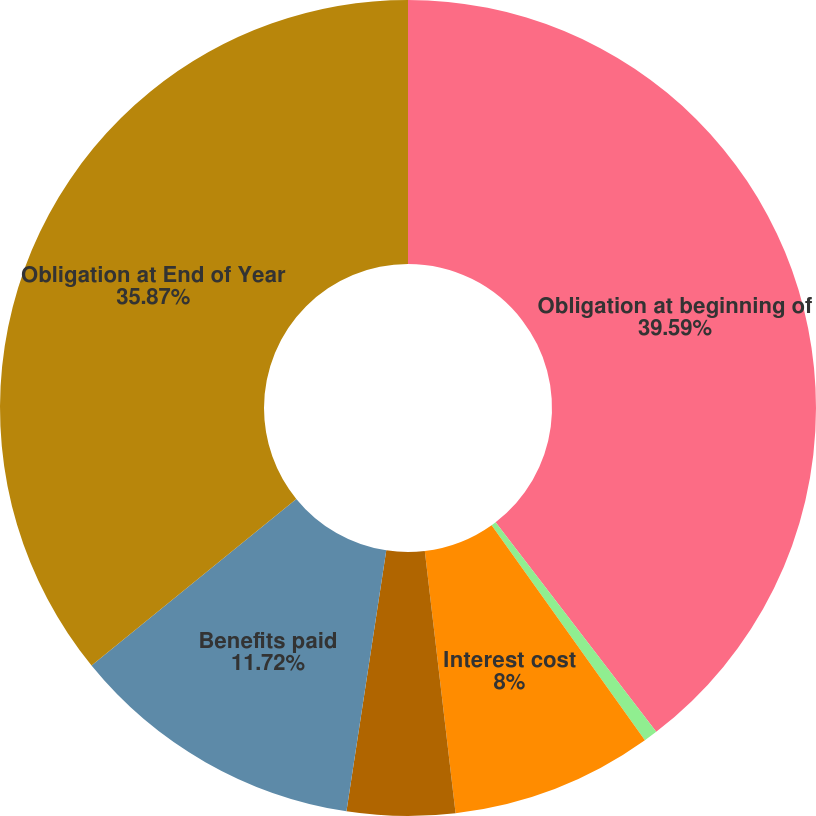Convert chart. <chart><loc_0><loc_0><loc_500><loc_500><pie_chart><fcel>Obligation at beginning of<fcel>Service cost<fcel>Interest cost<fcel>Actuarial gain<fcel>Benefits paid<fcel>Obligation at End of Year<nl><fcel>39.59%<fcel>0.55%<fcel>8.0%<fcel>4.27%<fcel>11.72%<fcel>35.87%<nl></chart> 